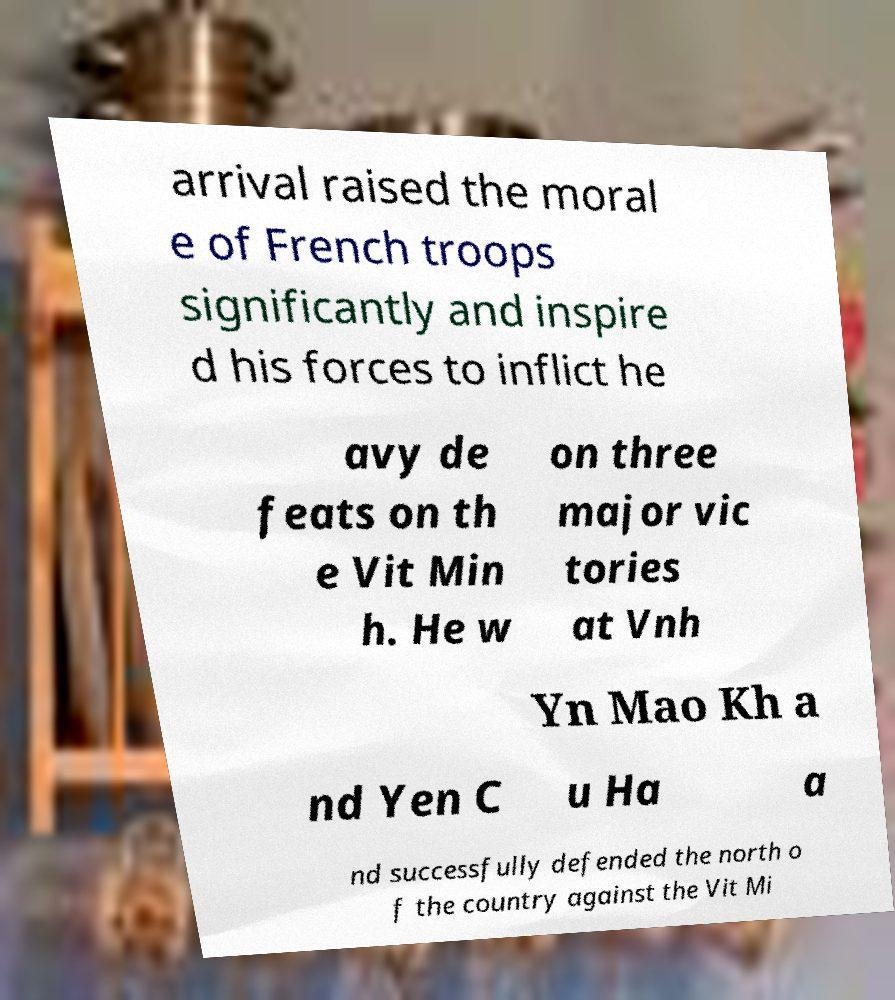I need the written content from this picture converted into text. Can you do that? arrival raised the moral e of French troops significantly and inspire d his forces to inflict he avy de feats on th e Vit Min h. He w on three major vic tories at Vnh Yn Mao Kh a nd Yen C u Ha a nd successfully defended the north o f the country against the Vit Mi 